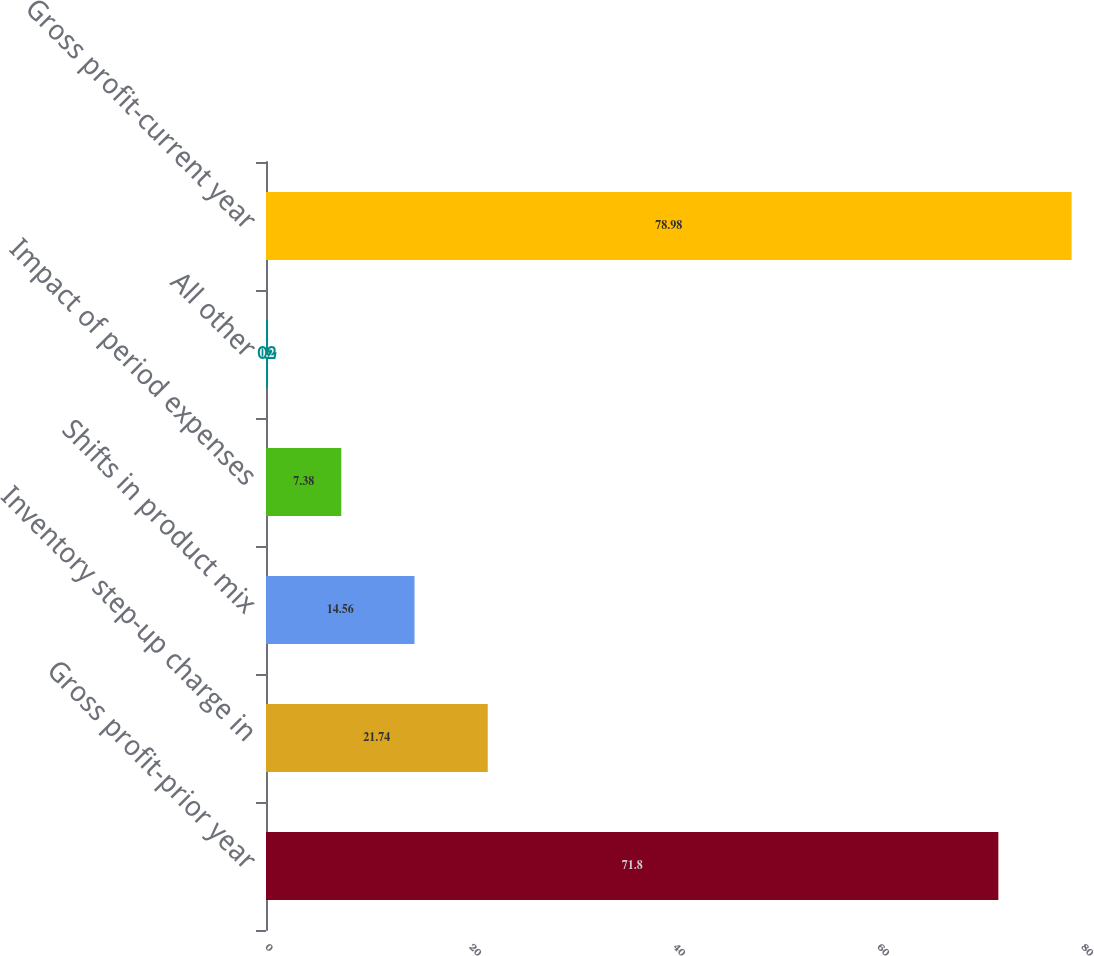<chart> <loc_0><loc_0><loc_500><loc_500><bar_chart><fcel>Gross profit-prior year<fcel>Inventory step-up charge in<fcel>Shifts in product mix<fcel>Impact of period expenses<fcel>All other<fcel>Gross profit-current year<nl><fcel>71.8<fcel>21.74<fcel>14.56<fcel>7.38<fcel>0.2<fcel>78.98<nl></chart> 